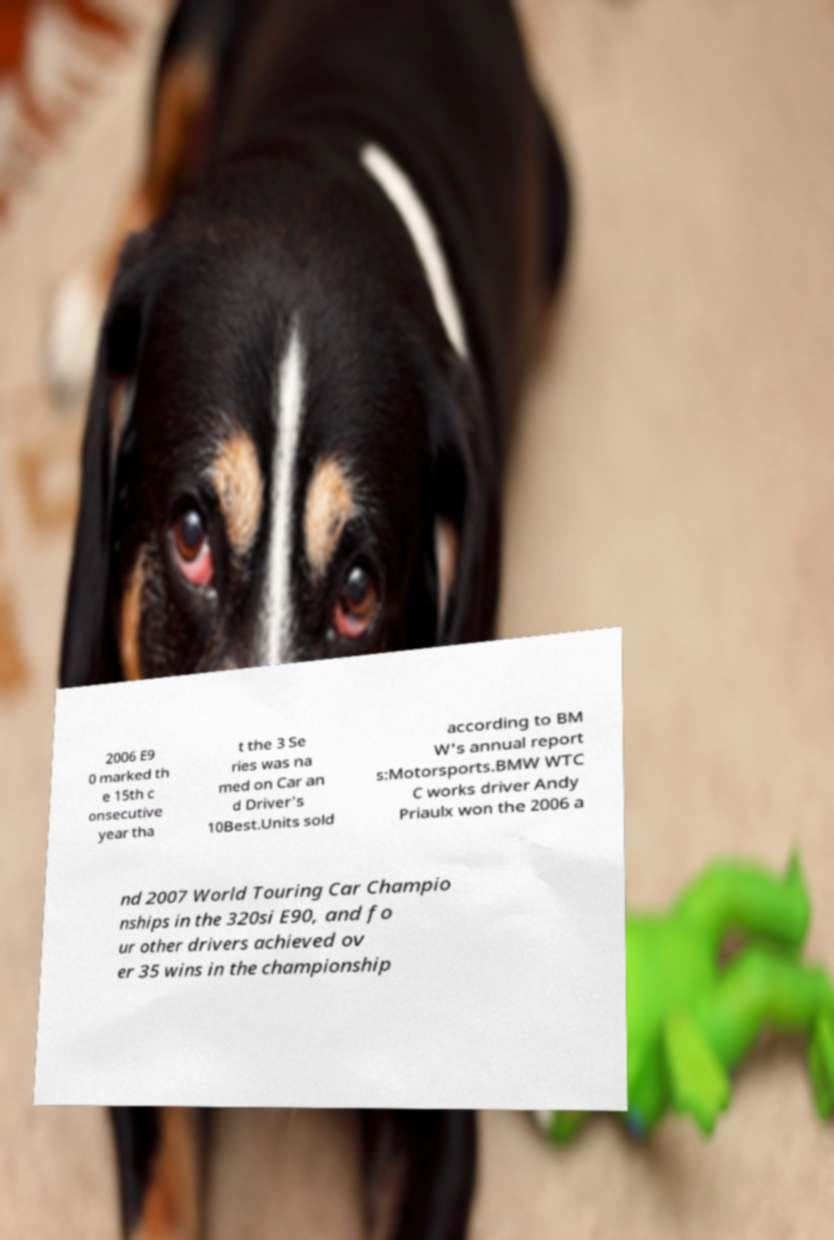Please read and relay the text visible in this image. What does it say? 2006 E9 0 marked th e 15th c onsecutive year tha t the 3 Se ries was na med on Car an d Driver's 10Best.Units sold according to BM W's annual report s:Motorsports.BMW WTC C works driver Andy Priaulx won the 2006 a nd 2007 World Touring Car Champio nships in the 320si E90, and fo ur other drivers achieved ov er 35 wins in the championship 